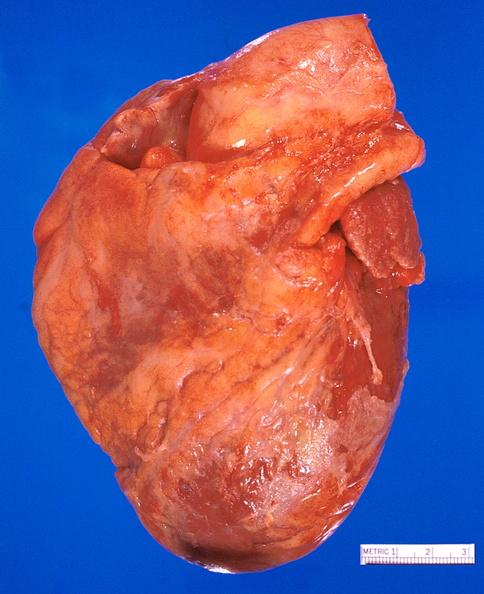what is present?
Answer the question using a single word or phrase. Cardiovascular 